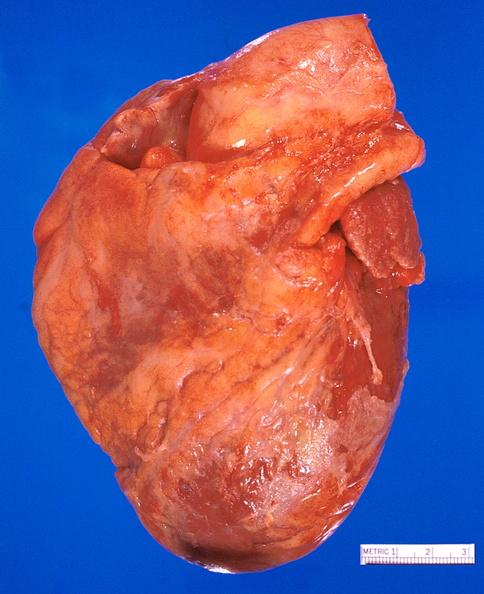what is present?
Answer the question using a single word or phrase. Cardiovascular 